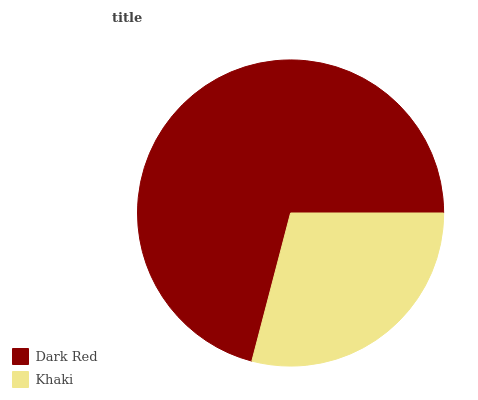Is Khaki the minimum?
Answer yes or no. Yes. Is Dark Red the maximum?
Answer yes or no. Yes. Is Khaki the maximum?
Answer yes or no. No. Is Dark Red greater than Khaki?
Answer yes or no. Yes. Is Khaki less than Dark Red?
Answer yes or no. Yes. Is Khaki greater than Dark Red?
Answer yes or no. No. Is Dark Red less than Khaki?
Answer yes or no. No. Is Dark Red the high median?
Answer yes or no. Yes. Is Khaki the low median?
Answer yes or no. Yes. Is Khaki the high median?
Answer yes or no. No. Is Dark Red the low median?
Answer yes or no. No. 